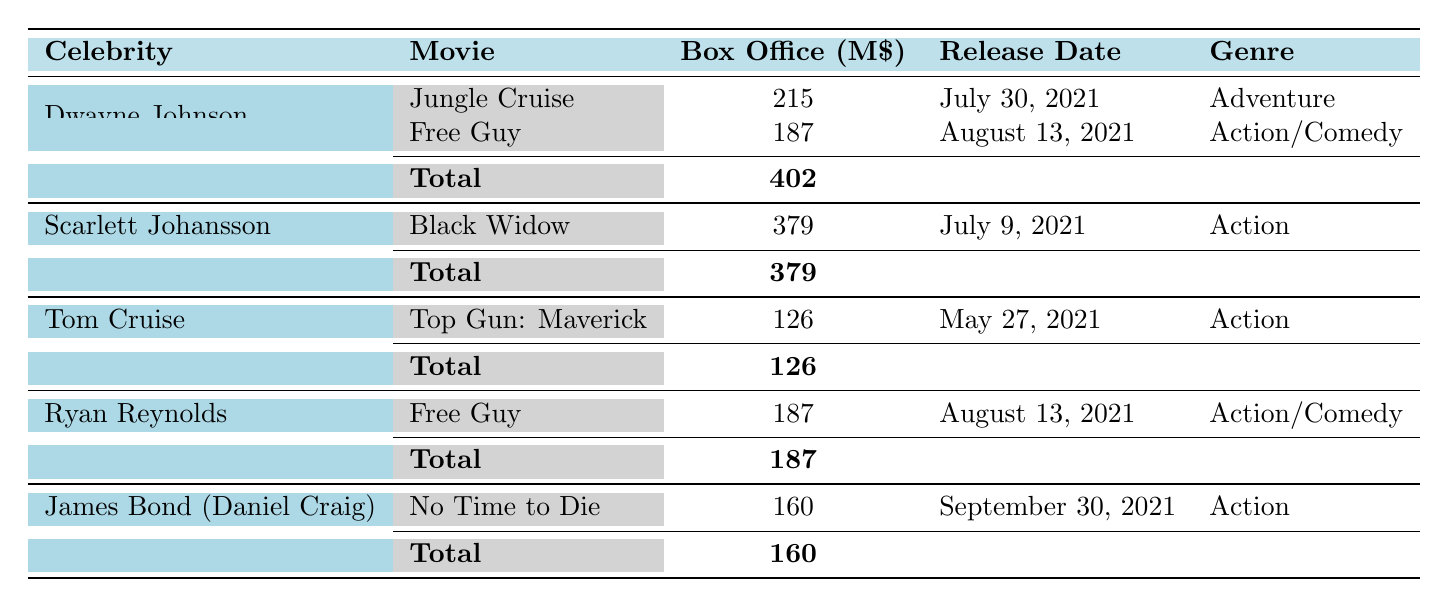What's the total box office gross for Dwayne Johnson's movies in 2021? Dwayne Johnson has two movies listed: Jungle Cruise with a box office gross of 215 million dollars, and Free Guy with a gross of 187 million dollars. To find the total box office gross, add these two amounts: 215 + 187 = 402 million dollars.
Answer: 402 million dollars Which movie starring Scarlett Johansson had the highest box office gross in 2021? Scarlett Johansson starred in one movie, Black Widow, which grossed 379 million dollars. Since it's the only movie listed for her, it's the highest by default.
Answer: Black Widow Did Tom Cruise have any movies with a box office gross of more than 150 million dollars in 2021? Tom Cruise starred in Top Gun: Maverick, which grossed 126 million dollars. No other movies are listed for him, and since 126 million is less than 150 million, the answer is no.
Answer: No What was the combined box office gross for movies starring Ryan Reynolds and Dwayne Johnson? Ryan Reynolds starred in Free Guy with a gross of 187 million dollars, and Dwayne Johnson had a total gross of 402 million dollars (from both movies). To find the combined gross, add these two totals: 187 + 402 = 589 million dollars.
Answer: 589 million dollars Was the release date of James Bond (Daniel Craig)'s movie earlier or later than July 9, 2021? James Bond (Daniel Craig)'s movie, No Time to Die, was released on September 30, 2021. Since September 30 is later than July 9, the answer is later.
Answer: Later Which genre had the highest total box office gross from the listed celebrities' movies? To find the highest grossing genre, sum the box office gross by genre: Adventure (215 million), Action/Comedy (187 + 187), and Action (379 + 126 + 160). The totals are: Adventure = 215, Action/Comedy = 374, Action = 665 million dollars. Action is the highest.
Answer: Action What is the average box office gross of the movies starring all listed celebrities? The total box office gross of all movies combined is 402 + 379 + 126 + 187 + 160 = 1254 million dollars. There are 5 movies in total, so to find the average, divide the total gross by the number of movies: 1254 / 5 = 250.8 million dollars.
Answer: 250.8 million dollars Did any of the films released in August 2021 exceed 200 million dollars in box office gross? The film Free Guy, released on August 13, 2021, grossed 187 million dollars. Since this is less than 200 million dollars, the answer is no.
Answer: No What is the total box office gross for the Action genre from the listed movies? For Action, the movies are: Black Widow (379 million), Top Gun: Maverick (126 million), and No Time to Die (160 million). Adding these amounts gives: 379 + 126 + 160 = 665 million dollars.
Answer: 665 million dollars 